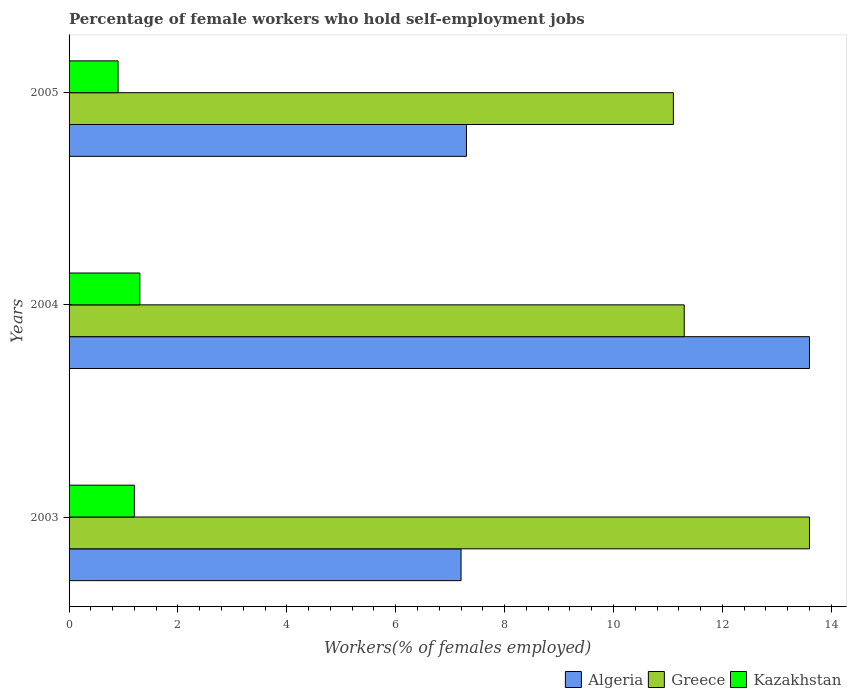Are the number of bars on each tick of the Y-axis equal?
Make the answer very short. Yes. How many bars are there on the 3rd tick from the bottom?
Keep it short and to the point. 3. What is the label of the 1st group of bars from the top?
Offer a very short reply. 2005. In how many cases, is the number of bars for a given year not equal to the number of legend labels?
Your answer should be very brief. 0. What is the percentage of self-employed female workers in Algeria in 2003?
Your response must be concise. 7.2. Across all years, what is the maximum percentage of self-employed female workers in Kazakhstan?
Make the answer very short. 1.3. Across all years, what is the minimum percentage of self-employed female workers in Greece?
Offer a very short reply. 11.1. In which year was the percentage of self-employed female workers in Greece maximum?
Offer a terse response. 2003. What is the total percentage of self-employed female workers in Algeria in the graph?
Make the answer very short. 28.1. What is the difference between the percentage of self-employed female workers in Greece in 2005 and the percentage of self-employed female workers in Algeria in 2003?
Give a very brief answer. 3.9. What is the average percentage of self-employed female workers in Kazakhstan per year?
Ensure brevity in your answer.  1.13. In the year 2005, what is the difference between the percentage of self-employed female workers in Kazakhstan and percentage of self-employed female workers in Algeria?
Your answer should be compact. -6.4. In how many years, is the percentage of self-employed female workers in Algeria greater than 12 %?
Give a very brief answer. 1. What is the ratio of the percentage of self-employed female workers in Greece in 2003 to that in 2004?
Ensure brevity in your answer.  1.2. Is the difference between the percentage of self-employed female workers in Kazakhstan in 2003 and 2004 greater than the difference between the percentage of self-employed female workers in Algeria in 2003 and 2004?
Your answer should be compact. Yes. What is the difference between the highest and the second highest percentage of self-employed female workers in Greece?
Your answer should be very brief. 2.3. What is the difference between the highest and the lowest percentage of self-employed female workers in Kazakhstan?
Ensure brevity in your answer.  0.4. Is the sum of the percentage of self-employed female workers in Algeria in 2004 and 2005 greater than the maximum percentage of self-employed female workers in Greece across all years?
Offer a very short reply. Yes. What does the 3rd bar from the top in 2005 represents?
Your answer should be compact. Algeria. What does the 1st bar from the bottom in 2005 represents?
Your answer should be very brief. Algeria. Is it the case that in every year, the sum of the percentage of self-employed female workers in Kazakhstan and percentage of self-employed female workers in Greece is greater than the percentage of self-employed female workers in Algeria?
Offer a very short reply. No. How many years are there in the graph?
Give a very brief answer. 3. What is the difference between two consecutive major ticks on the X-axis?
Provide a short and direct response. 2. Does the graph contain grids?
Offer a very short reply. No. Where does the legend appear in the graph?
Make the answer very short. Bottom right. How many legend labels are there?
Your answer should be very brief. 3. How are the legend labels stacked?
Offer a terse response. Horizontal. What is the title of the graph?
Provide a succinct answer. Percentage of female workers who hold self-employment jobs. Does "Gambia, The" appear as one of the legend labels in the graph?
Offer a very short reply. No. What is the label or title of the X-axis?
Make the answer very short. Workers(% of females employed). What is the Workers(% of females employed) in Algeria in 2003?
Ensure brevity in your answer.  7.2. What is the Workers(% of females employed) of Greece in 2003?
Ensure brevity in your answer.  13.6. What is the Workers(% of females employed) of Kazakhstan in 2003?
Ensure brevity in your answer.  1.2. What is the Workers(% of females employed) in Algeria in 2004?
Offer a terse response. 13.6. What is the Workers(% of females employed) of Greece in 2004?
Ensure brevity in your answer.  11.3. What is the Workers(% of females employed) of Kazakhstan in 2004?
Provide a succinct answer. 1.3. What is the Workers(% of females employed) in Algeria in 2005?
Make the answer very short. 7.3. What is the Workers(% of females employed) of Greece in 2005?
Make the answer very short. 11.1. What is the Workers(% of females employed) in Kazakhstan in 2005?
Your answer should be very brief. 0.9. Across all years, what is the maximum Workers(% of females employed) of Algeria?
Offer a terse response. 13.6. Across all years, what is the maximum Workers(% of females employed) of Greece?
Your answer should be very brief. 13.6. Across all years, what is the maximum Workers(% of females employed) in Kazakhstan?
Your answer should be compact. 1.3. Across all years, what is the minimum Workers(% of females employed) in Algeria?
Keep it short and to the point. 7.2. Across all years, what is the minimum Workers(% of females employed) in Greece?
Your response must be concise. 11.1. Across all years, what is the minimum Workers(% of females employed) of Kazakhstan?
Offer a very short reply. 0.9. What is the total Workers(% of females employed) in Algeria in the graph?
Your response must be concise. 28.1. What is the total Workers(% of females employed) in Greece in the graph?
Make the answer very short. 36. What is the total Workers(% of females employed) in Kazakhstan in the graph?
Provide a short and direct response. 3.4. What is the difference between the Workers(% of females employed) of Algeria in 2003 and that in 2004?
Keep it short and to the point. -6.4. What is the difference between the Workers(% of females employed) of Greece in 2003 and that in 2004?
Make the answer very short. 2.3. What is the difference between the Workers(% of females employed) in Kazakhstan in 2003 and that in 2004?
Ensure brevity in your answer.  -0.1. What is the difference between the Workers(% of females employed) in Algeria in 2003 and that in 2005?
Give a very brief answer. -0.1. What is the difference between the Workers(% of females employed) of Kazakhstan in 2003 and that in 2005?
Offer a terse response. 0.3. What is the difference between the Workers(% of females employed) of Greece in 2004 and that in 2005?
Provide a succinct answer. 0.2. What is the difference between the Workers(% of females employed) of Algeria in 2003 and the Workers(% of females employed) of Greece in 2004?
Keep it short and to the point. -4.1. What is the difference between the Workers(% of females employed) in Algeria in 2004 and the Workers(% of females employed) in Kazakhstan in 2005?
Keep it short and to the point. 12.7. What is the difference between the Workers(% of females employed) of Greece in 2004 and the Workers(% of females employed) of Kazakhstan in 2005?
Keep it short and to the point. 10.4. What is the average Workers(% of females employed) in Algeria per year?
Keep it short and to the point. 9.37. What is the average Workers(% of females employed) of Greece per year?
Your answer should be very brief. 12. What is the average Workers(% of females employed) of Kazakhstan per year?
Give a very brief answer. 1.13. In the year 2003, what is the difference between the Workers(% of females employed) of Algeria and Workers(% of females employed) of Kazakhstan?
Your response must be concise. 6. In the year 2004, what is the difference between the Workers(% of females employed) of Algeria and Workers(% of females employed) of Greece?
Keep it short and to the point. 2.3. In the year 2004, what is the difference between the Workers(% of females employed) in Greece and Workers(% of females employed) in Kazakhstan?
Your response must be concise. 10. In the year 2005, what is the difference between the Workers(% of females employed) in Greece and Workers(% of females employed) in Kazakhstan?
Give a very brief answer. 10.2. What is the ratio of the Workers(% of females employed) of Algeria in 2003 to that in 2004?
Your response must be concise. 0.53. What is the ratio of the Workers(% of females employed) in Greece in 2003 to that in 2004?
Offer a terse response. 1.2. What is the ratio of the Workers(% of females employed) of Kazakhstan in 2003 to that in 2004?
Offer a terse response. 0.92. What is the ratio of the Workers(% of females employed) in Algeria in 2003 to that in 2005?
Your response must be concise. 0.99. What is the ratio of the Workers(% of females employed) of Greece in 2003 to that in 2005?
Make the answer very short. 1.23. What is the ratio of the Workers(% of females employed) of Kazakhstan in 2003 to that in 2005?
Your answer should be very brief. 1.33. What is the ratio of the Workers(% of females employed) in Algeria in 2004 to that in 2005?
Offer a very short reply. 1.86. What is the ratio of the Workers(% of females employed) of Greece in 2004 to that in 2005?
Your answer should be very brief. 1.02. What is the ratio of the Workers(% of females employed) of Kazakhstan in 2004 to that in 2005?
Your answer should be very brief. 1.44. What is the difference between the highest and the second highest Workers(% of females employed) of Algeria?
Make the answer very short. 6.3. What is the difference between the highest and the lowest Workers(% of females employed) in Kazakhstan?
Ensure brevity in your answer.  0.4. 